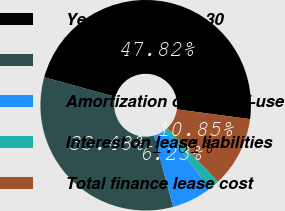Convert chart to OTSL. <chart><loc_0><loc_0><loc_500><loc_500><pie_chart><fcel>Year Ended June 30<fcel>Operating lease cost<fcel>Amortization of right-of-use<fcel>Interest on lease liabilities<fcel>Total finance lease cost<nl><fcel>47.82%<fcel>33.48%<fcel>6.23%<fcel>1.61%<fcel>10.85%<nl></chart> 